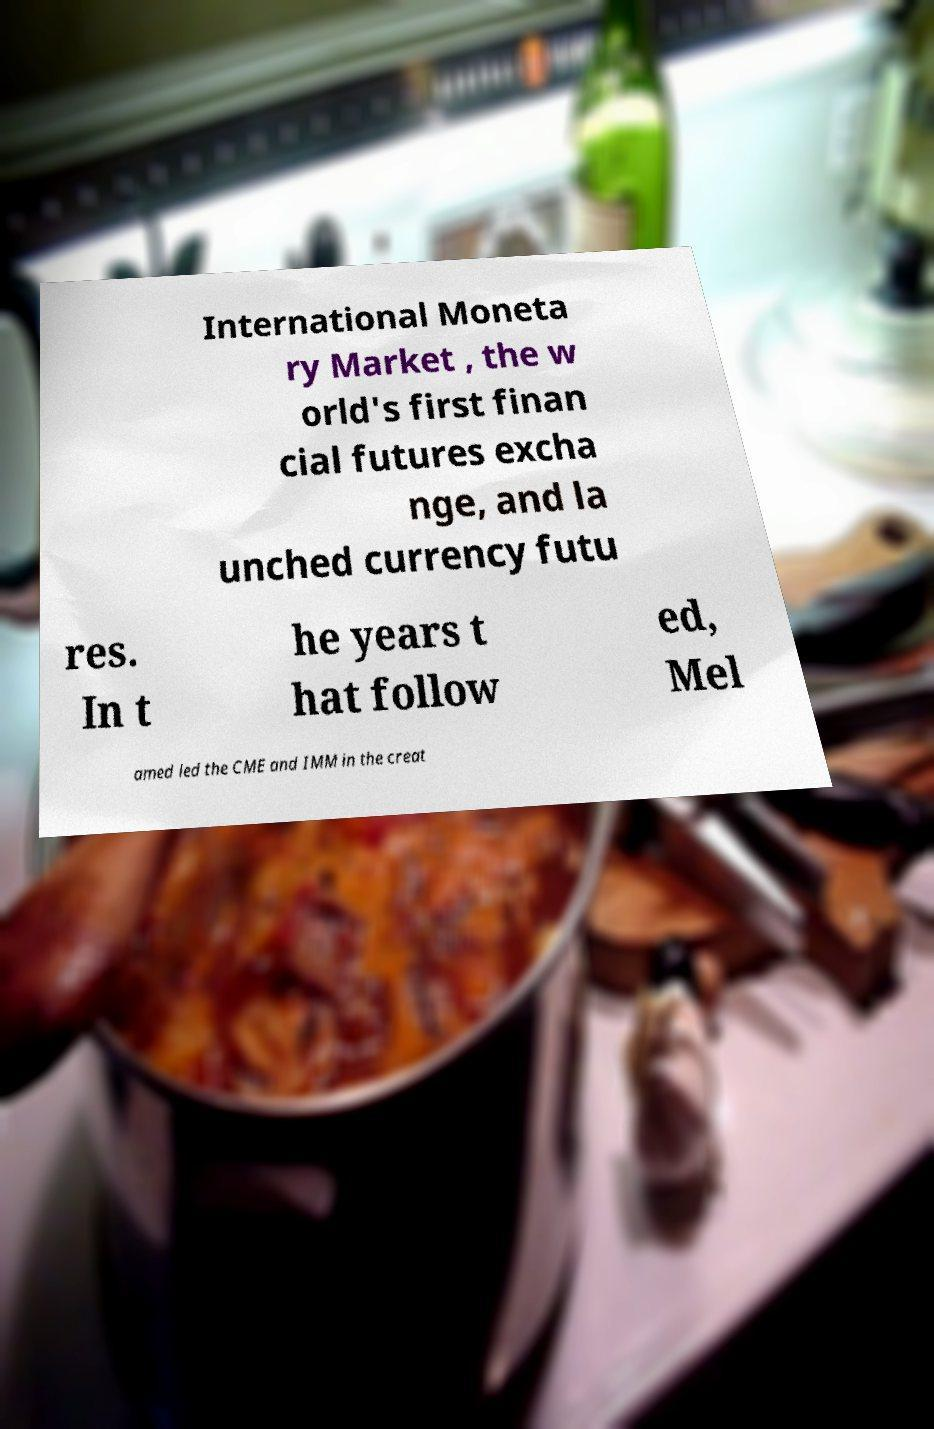For documentation purposes, I need the text within this image transcribed. Could you provide that? International Moneta ry Market , the w orld's first finan cial futures excha nge, and la unched currency futu res. In t he years t hat follow ed, Mel amed led the CME and IMM in the creat 